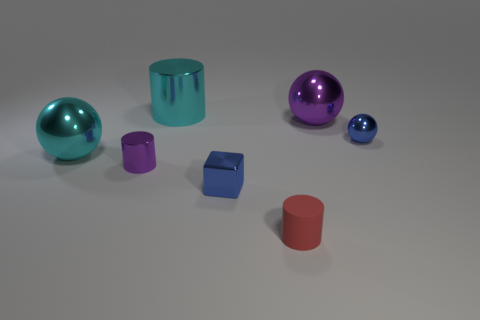What number of big green shiny cubes are there?
Give a very brief answer. 0. What shape is the blue thing that is the same material as the small blue cube?
Your response must be concise. Sphere. Is there any other thing that has the same color as the big cylinder?
Keep it short and to the point. Yes. Do the shiny block and the big metallic ball to the right of the tiny rubber thing have the same color?
Make the answer very short. No. Is the number of tiny red rubber objects that are behind the tiny purple metallic thing less than the number of purple matte cubes?
Offer a terse response. No. There is a blue object on the right side of the big purple metallic ball; what is it made of?
Offer a terse response. Metal. How many other objects are the same size as the metal block?
Your answer should be compact. 3. Does the purple metal cylinder have the same size as the blue metallic thing behind the tiny purple shiny cylinder?
Offer a terse response. Yes. There is a purple metallic thing that is in front of the small blue metallic thing that is right of the big sphere that is right of the red rubber cylinder; what shape is it?
Make the answer very short. Cylinder. Is the number of tiny blue objects less than the number of small green cylinders?
Ensure brevity in your answer.  No. 